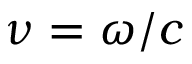Convert formula to latex. <formula><loc_0><loc_0><loc_500><loc_500>\nu = \omega / c</formula> 